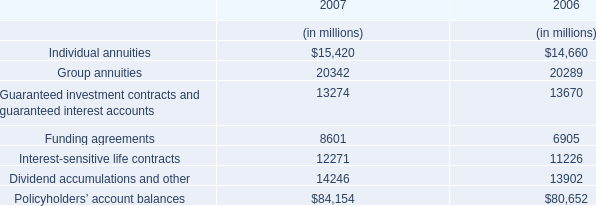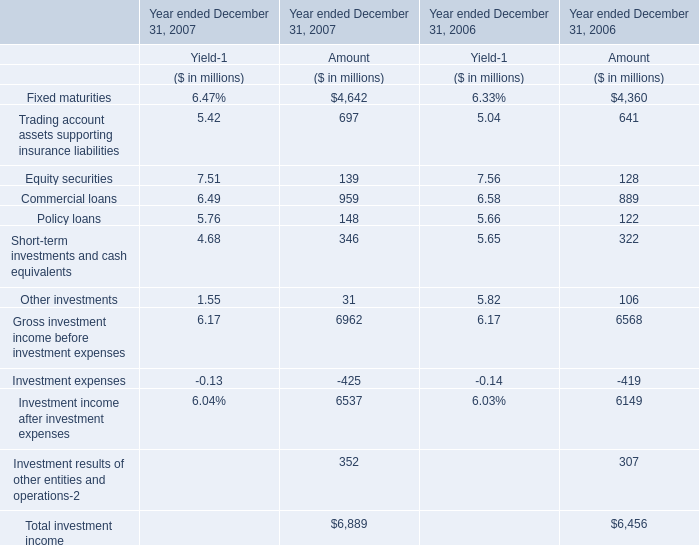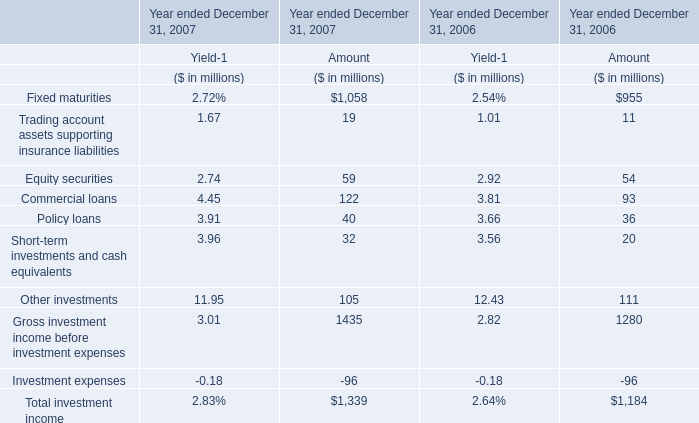What is the sum of 4 Trading account assets supporting insurance liabilities , Equity securities and Commercial loans in 2007？ (in million) 
Computations: ((697 + 139) + 959)
Answer: 1795.0. 